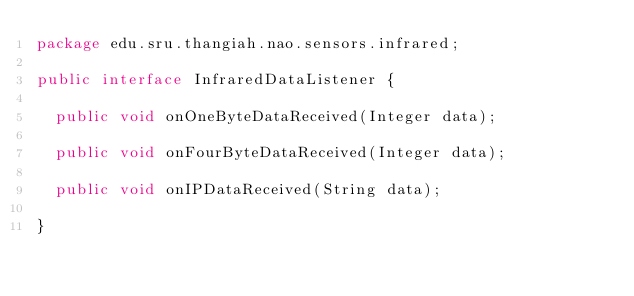<code> <loc_0><loc_0><loc_500><loc_500><_Java_>package edu.sru.thangiah.nao.sensors.infrared;

public interface InfraredDataListener {
	
	public void onOneByteDataReceived(Integer data);
	
	public void onFourByteDataReceived(Integer data);
	
	public void onIPDataReceived(String data);

}
</code> 